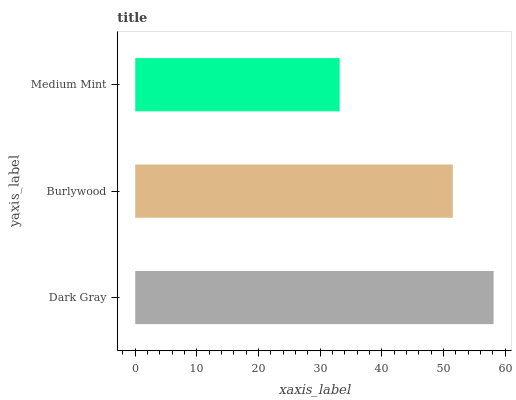Is Medium Mint the minimum?
Answer yes or no. Yes. Is Dark Gray the maximum?
Answer yes or no. Yes. Is Burlywood the minimum?
Answer yes or no. No. Is Burlywood the maximum?
Answer yes or no. No. Is Dark Gray greater than Burlywood?
Answer yes or no. Yes. Is Burlywood less than Dark Gray?
Answer yes or no. Yes. Is Burlywood greater than Dark Gray?
Answer yes or no. No. Is Dark Gray less than Burlywood?
Answer yes or no. No. Is Burlywood the high median?
Answer yes or no. Yes. Is Burlywood the low median?
Answer yes or no. Yes. Is Dark Gray the high median?
Answer yes or no. No. Is Dark Gray the low median?
Answer yes or no. No. 